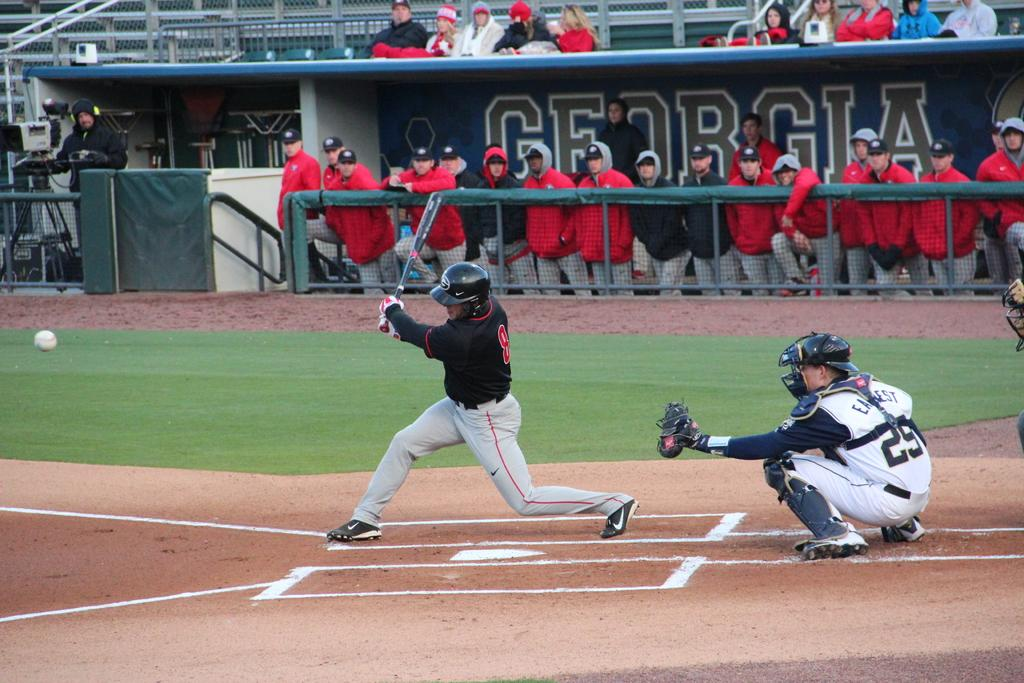<image>
Give a short and clear explanation of the subsequent image. a dugout that has the state name of Georgia in it 